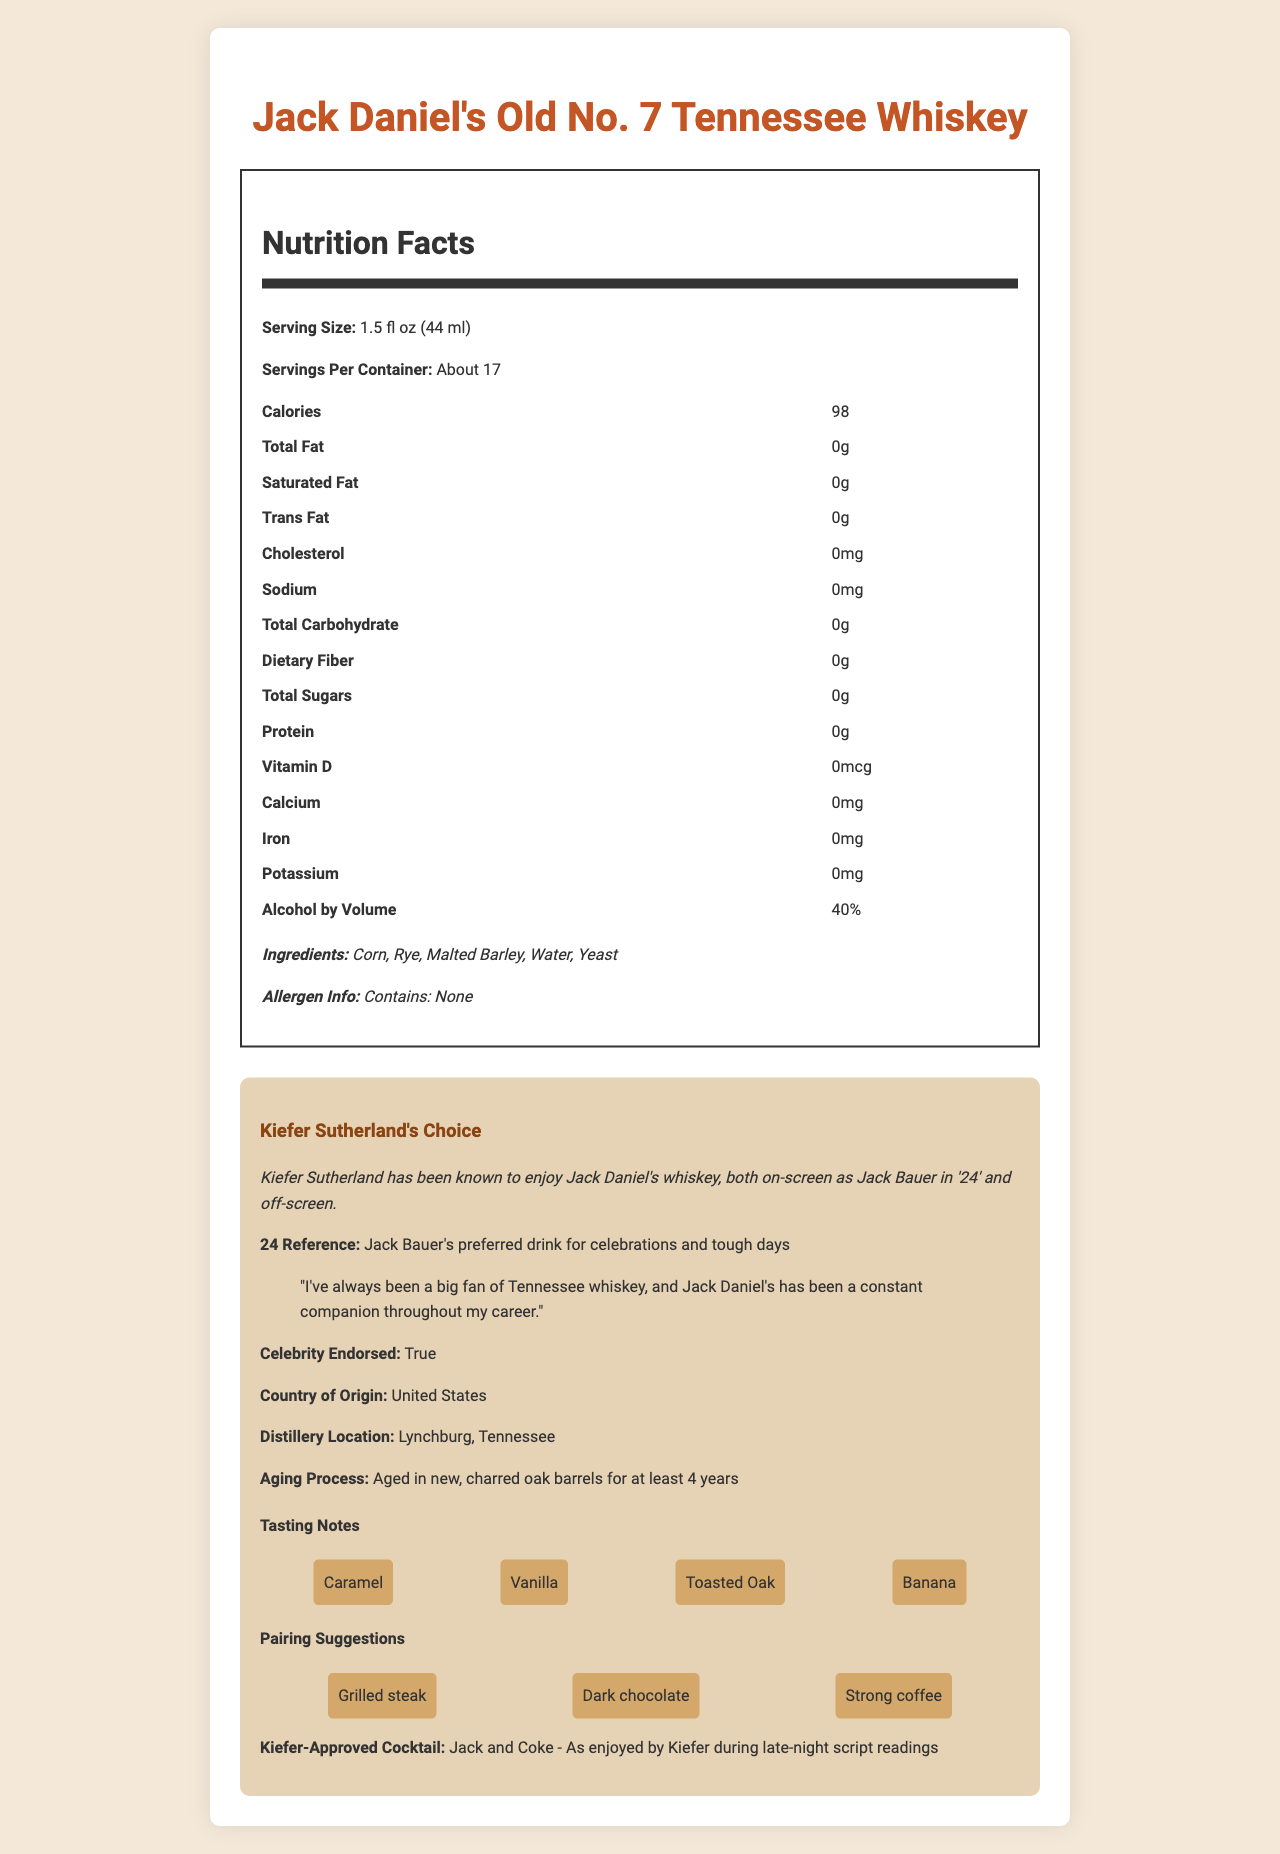who is known to enjoy Jack Daniel's whiskey frequently? Based on the document, Kiefer Sutherland is known to enjoy Jack Daniel's whiskey, both on-screen as Jack Bauer in '24' and off-screen.
Answer: Kiefer Sutherland what is the serving size for Jack Daniel's Old No. 7 Tennessee Whiskey? The document mentions that the serving size is 1.5 fl oz (44 ml).
Answer: 1.5 fl oz (44 ml) how many calories are there per serving? According to the nutrition facts, there are 98 calories per serving.
Answer: 98 what are the primary ingredients in Jack Daniel's Old No. 7 Tennessee Whiskey? The ingredients listed in the document are Corn, Rye, Malted Barley, Water, and Yeast.
Answer: Corn, Rye, Malted Barley, Water, Yeast what pairs well with Jack Daniel's Old No. 7 Tennessee Whiskey? The pairing suggestions in the document are Grilled steak, Dark chocolate, and Strong coffee.
Answer: Grilled steak, Dark chocolate, Strong coffee what is the alcohol by volume (ABV) percentage of this whiskey? The document states that the alcohol by volume (ABV) is 40%.
Answer: 40% where is the distillery for Jack Daniel's located? The distillery location is Lynchburg, Tennessee, as mentioned in the document.
Answer: Lynchburg, Tennessee how long is Jack Daniel's Old No. 7 Tennessee Whiskey aged? The aging process describes that the whiskey is aged in new, charred oak barrels for at least 4 years.
Answer: At least 4 years does the whiskey contain any allergens? (Yes/No) The allergen info section states, "Contains: None," indicating no allergens are present.
Answer: No what are the notable tasting notes for Jack Daniel's Old No. 7 Tennessee Whiskey? A. Caramel B. Banana C. Dark chocolate D. Both A and B E. All of the above The tasting notes include Caramel, Vanilla, Toasted Oak, and Banana, making both Caramel and Banana correct.
Answer: D what quote from Kiefer Sutherland is mentioned regarding his preference for Jack Daniel's whiskey? A. "I love whiskey" B. "I've always been a big fan of Tennessee whiskey..." C. "Whiskey is overrated" The document quotes Kiefer saying, "I've always been a big fan of Tennessee whiskey, and Jack Daniel's has been a constant companion throughout my career."
Answer: B describe the main characteristics and details of Jack Daniel's Old No. 7 Tennessee Whiskey as presented in the document. The document provides comprehensive details about Jack Daniel's Old No. 7 Tennessee Whiskey, including its nutritional info, ingredients, aging process, and tasting notes, coupled with Kiefer Sutherland's endorsement.
Answer: Jack Daniel's Old No. 7 Tennessee Whiskey is a popular beverage with a serving size of 1.5 fl oz containing 98 calories. It is composed of Corn, Rye, Malted Barley, Water, and Yeast, and has an ABV of 40%. The whiskey is known for its tasting notes of Caramel, Vanilla, Toasted Oak, and Banana, and pairs well with Grilled steak, Dark chocolate, and Strong coffee. This whiskey is aged for at least 4 years in Lynchburg, Tennessee. Kiefer Sutherland, a big fan of Tennessee whiskey, endorses this brand. is Jack Daniel's Old No. 7 Tennessee Whiskey endorsed by any celebrity? The document confirms that Jack Daniel's is endorsed by the celebrity Kiefer Sutherland.
Answer: Yes how many servings are approximately in one container? The document mentions that there are about 17 servings per container.
Answer: About 17 who makes Jack and Coke cocktails during late-night script readings? The document states that Kiefer enjoys Jack and Coke during late-night script readings.
Answer: Kiefer Sutherland what kind of whiskey does Jack Bauer prefer? The document references Jack Bauer's preferred drink as Jack Daniel's Tennessee whiskey.
Answer: Tennessee whiskey, specifically Jack Daniel's what are the potassium levels in one serving of Jack Daniel's Old No. 7 Tennessee Whiskey? The nutrition facts label in the document shows that potassium levels are 0mg per serving.
Answer: 0mg what other spirit is often combined with Jack Daniel's to make a "Kiefer-approved cocktail"? The document mentions that Kiefer approves of the "Jack and Coke" cocktail.
Answer: Coca-Cola (Coke) what is the price of Jack Daniel's Old No. 7 Tennessee Whiskey? The document does not provide any information regarding the price of the whiskey.
Answer: Cannot be determined 